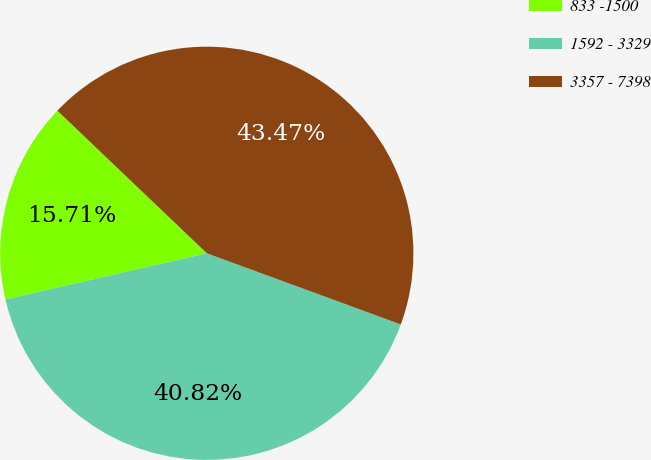<chart> <loc_0><loc_0><loc_500><loc_500><pie_chart><fcel>833 -1500<fcel>1592 - 3329<fcel>3357 - 7398<nl><fcel>15.71%<fcel>40.82%<fcel>43.47%<nl></chart> 